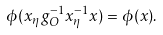<formula> <loc_0><loc_0><loc_500><loc_500>\phi ( x _ { \eta } g _ { O } ^ { - 1 } x _ { \eta } ^ { - 1 } x ) = \phi ( x ) .</formula> 